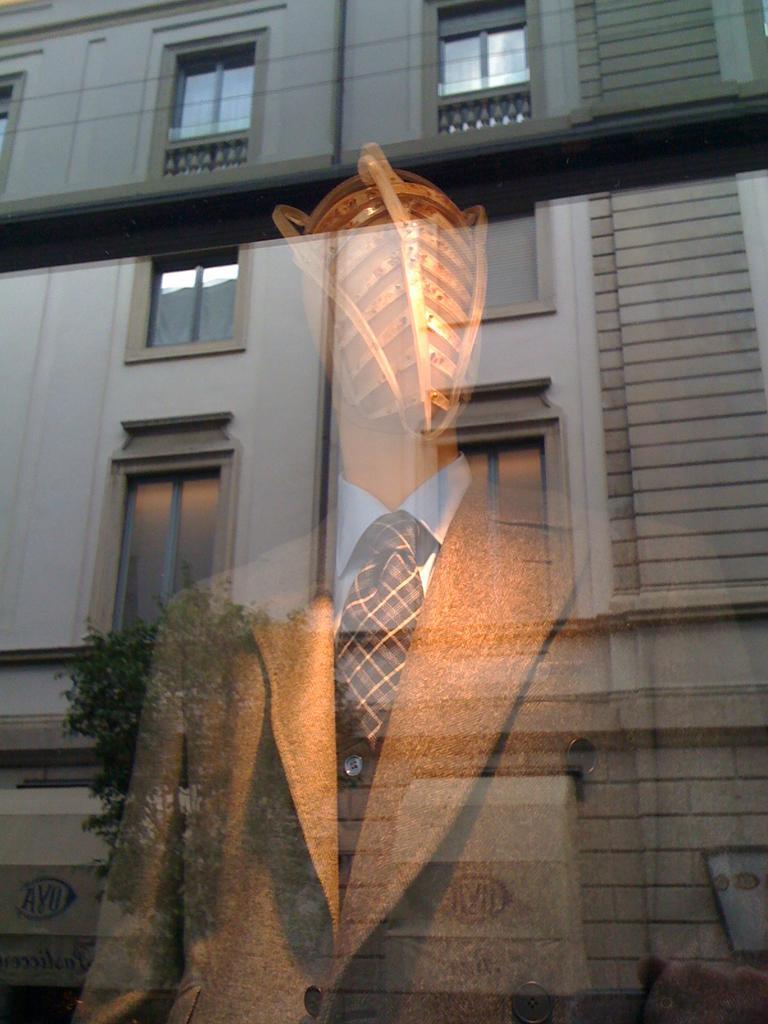Could you give a brief overview of what you see in this image? In the picture I can see a building which has windows. I can also see a tree and a mannequin which has a coat, a tie and a shirt on it. 